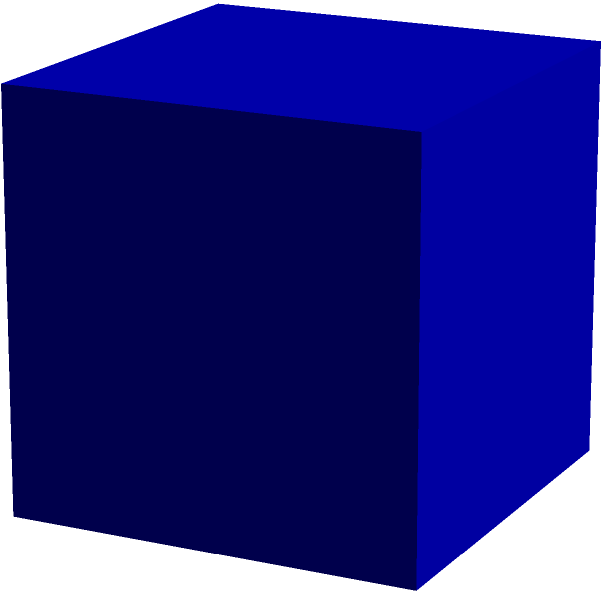As part of your community service initiative, you've decided to create cube-shaped donation boxes for local charities. If each edge of the donation box measures 12 cm, what is the total surface area of one box in square centimeters? Let's approach this step-by-step:

1) First, recall the formula for the surface area of a cube:
   $SA = 6s^2$, where $s$ is the length of one edge.

2) We're given that each edge measures 12 cm, so $s = 12$ cm.

3) Let's substitute this into our formula:
   $SA = 6 \times (12 \text{ cm})^2$

4) Now, let's calculate:
   $SA = 6 \times 144 \text{ cm}^2$

5) Simplify:
   $SA = 864 \text{ cm}^2$

Therefore, the total surface area of one donation box is 864 square centimeters.
Answer: $864 \text{ cm}^2$ 